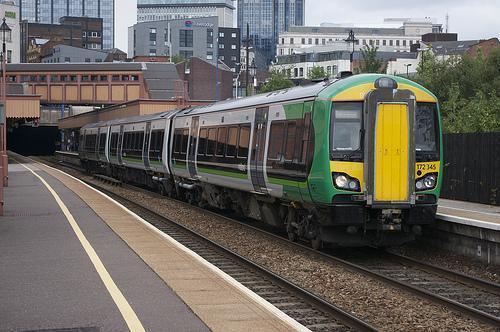How many trains are visible?
Give a very brief answer. 1. How many train cars are there?
Give a very brief answer. 3. 